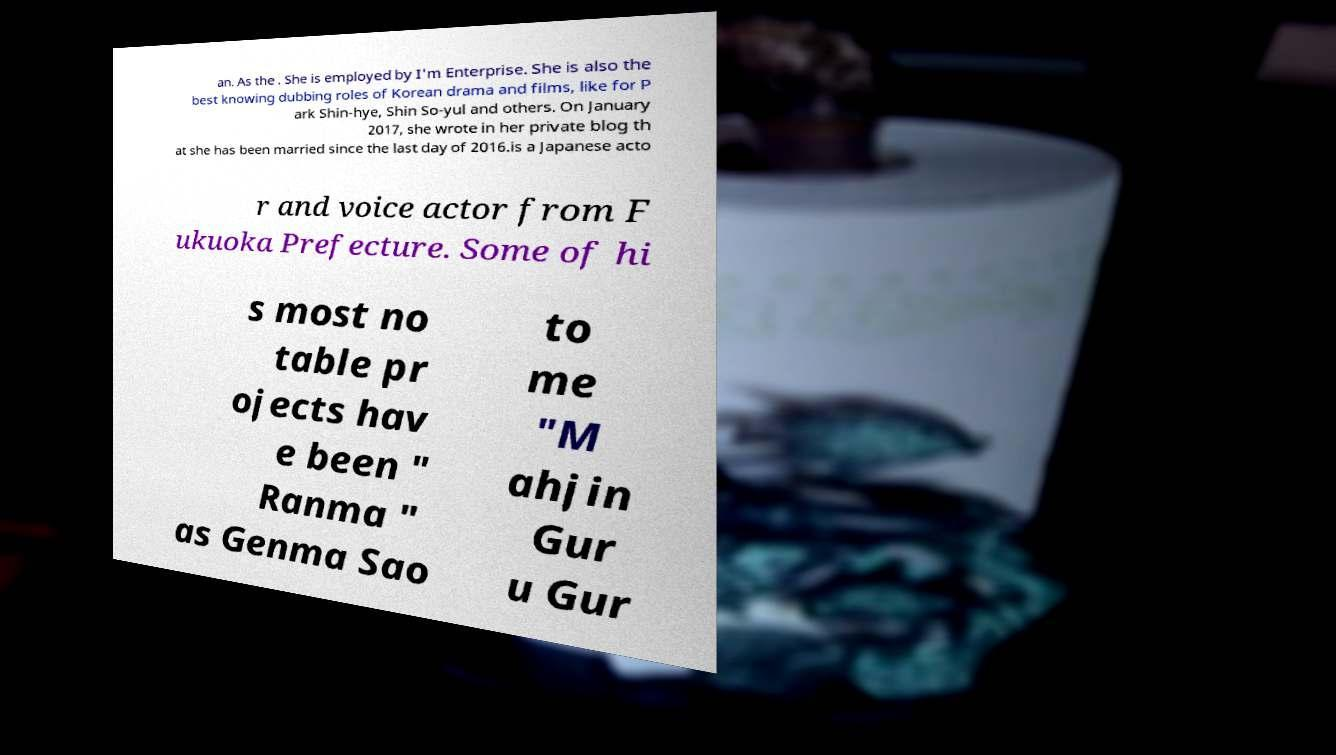There's text embedded in this image that I need extracted. Can you transcribe it verbatim? an. As the . She is employed by I'm Enterprise. She is also the best knowing dubbing roles of Korean drama and films, like for P ark Shin-hye, Shin So-yul and others. On January 2017, she wrote in her private blog th at she has been married since the last day of 2016.is a Japanese acto r and voice actor from F ukuoka Prefecture. Some of hi s most no table pr ojects hav e been " Ranma " as Genma Sao to me "M ahjin Gur u Gur 